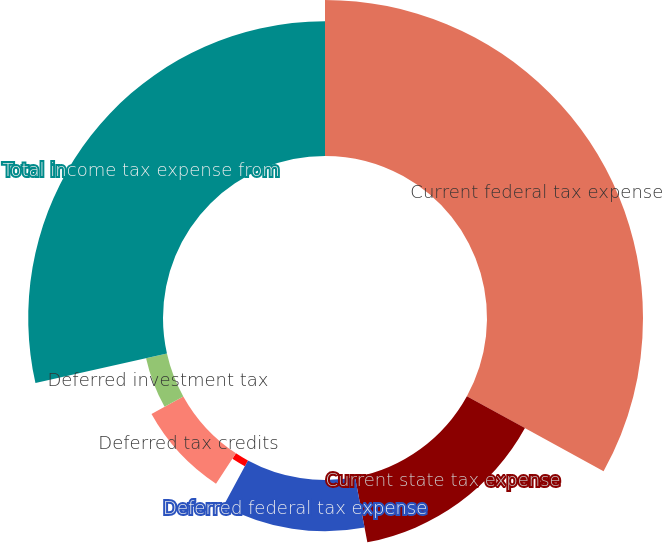<chart> <loc_0><loc_0><loc_500><loc_500><pie_chart><fcel>Current federal tax expense<fcel>Current state tax expense<fcel>Deferred federal tax expense<fcel>Deferred statetax expense<fcel>Deferred tax credits<fcel>Deferred investment tax<fcel>Total income tax expense from<nl><fcel>33.01%<fcel>14.02%<fcel>10.86%<fcel>1.37%<fcel>7.69%<fcel>4.53%<fcel>28.52%<nl></chart> 